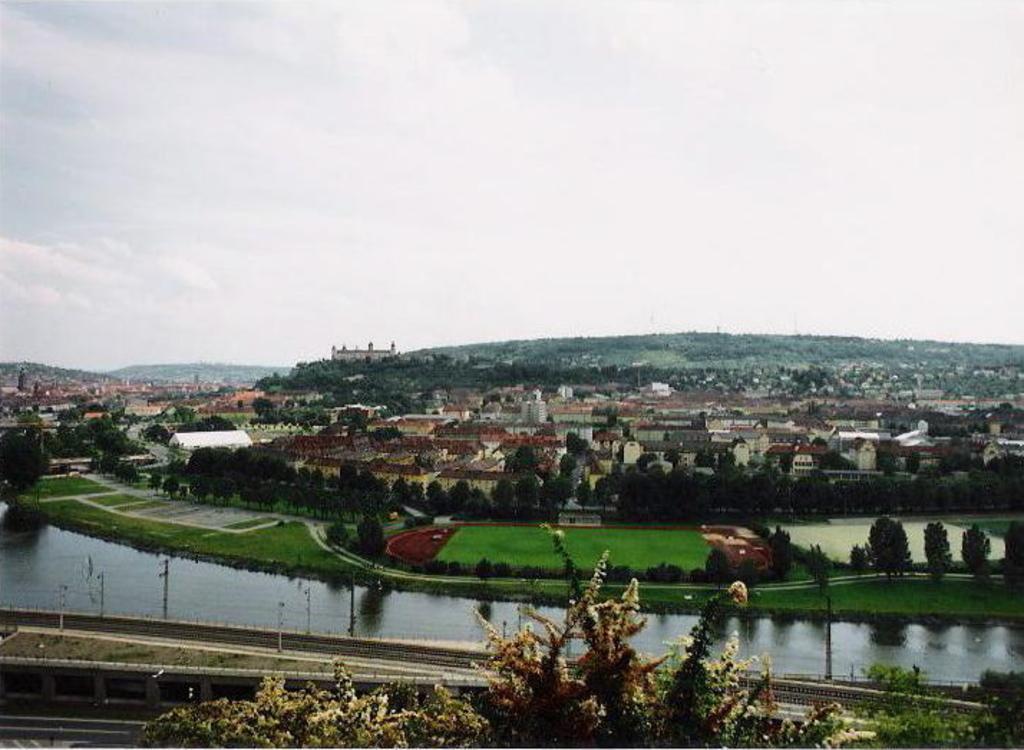How would you summarize this image in a sentence or two? In the background we can see the sky, hills and the thicket. In this picture we can see the buildings, trees, grass, water, poles and bridge. 